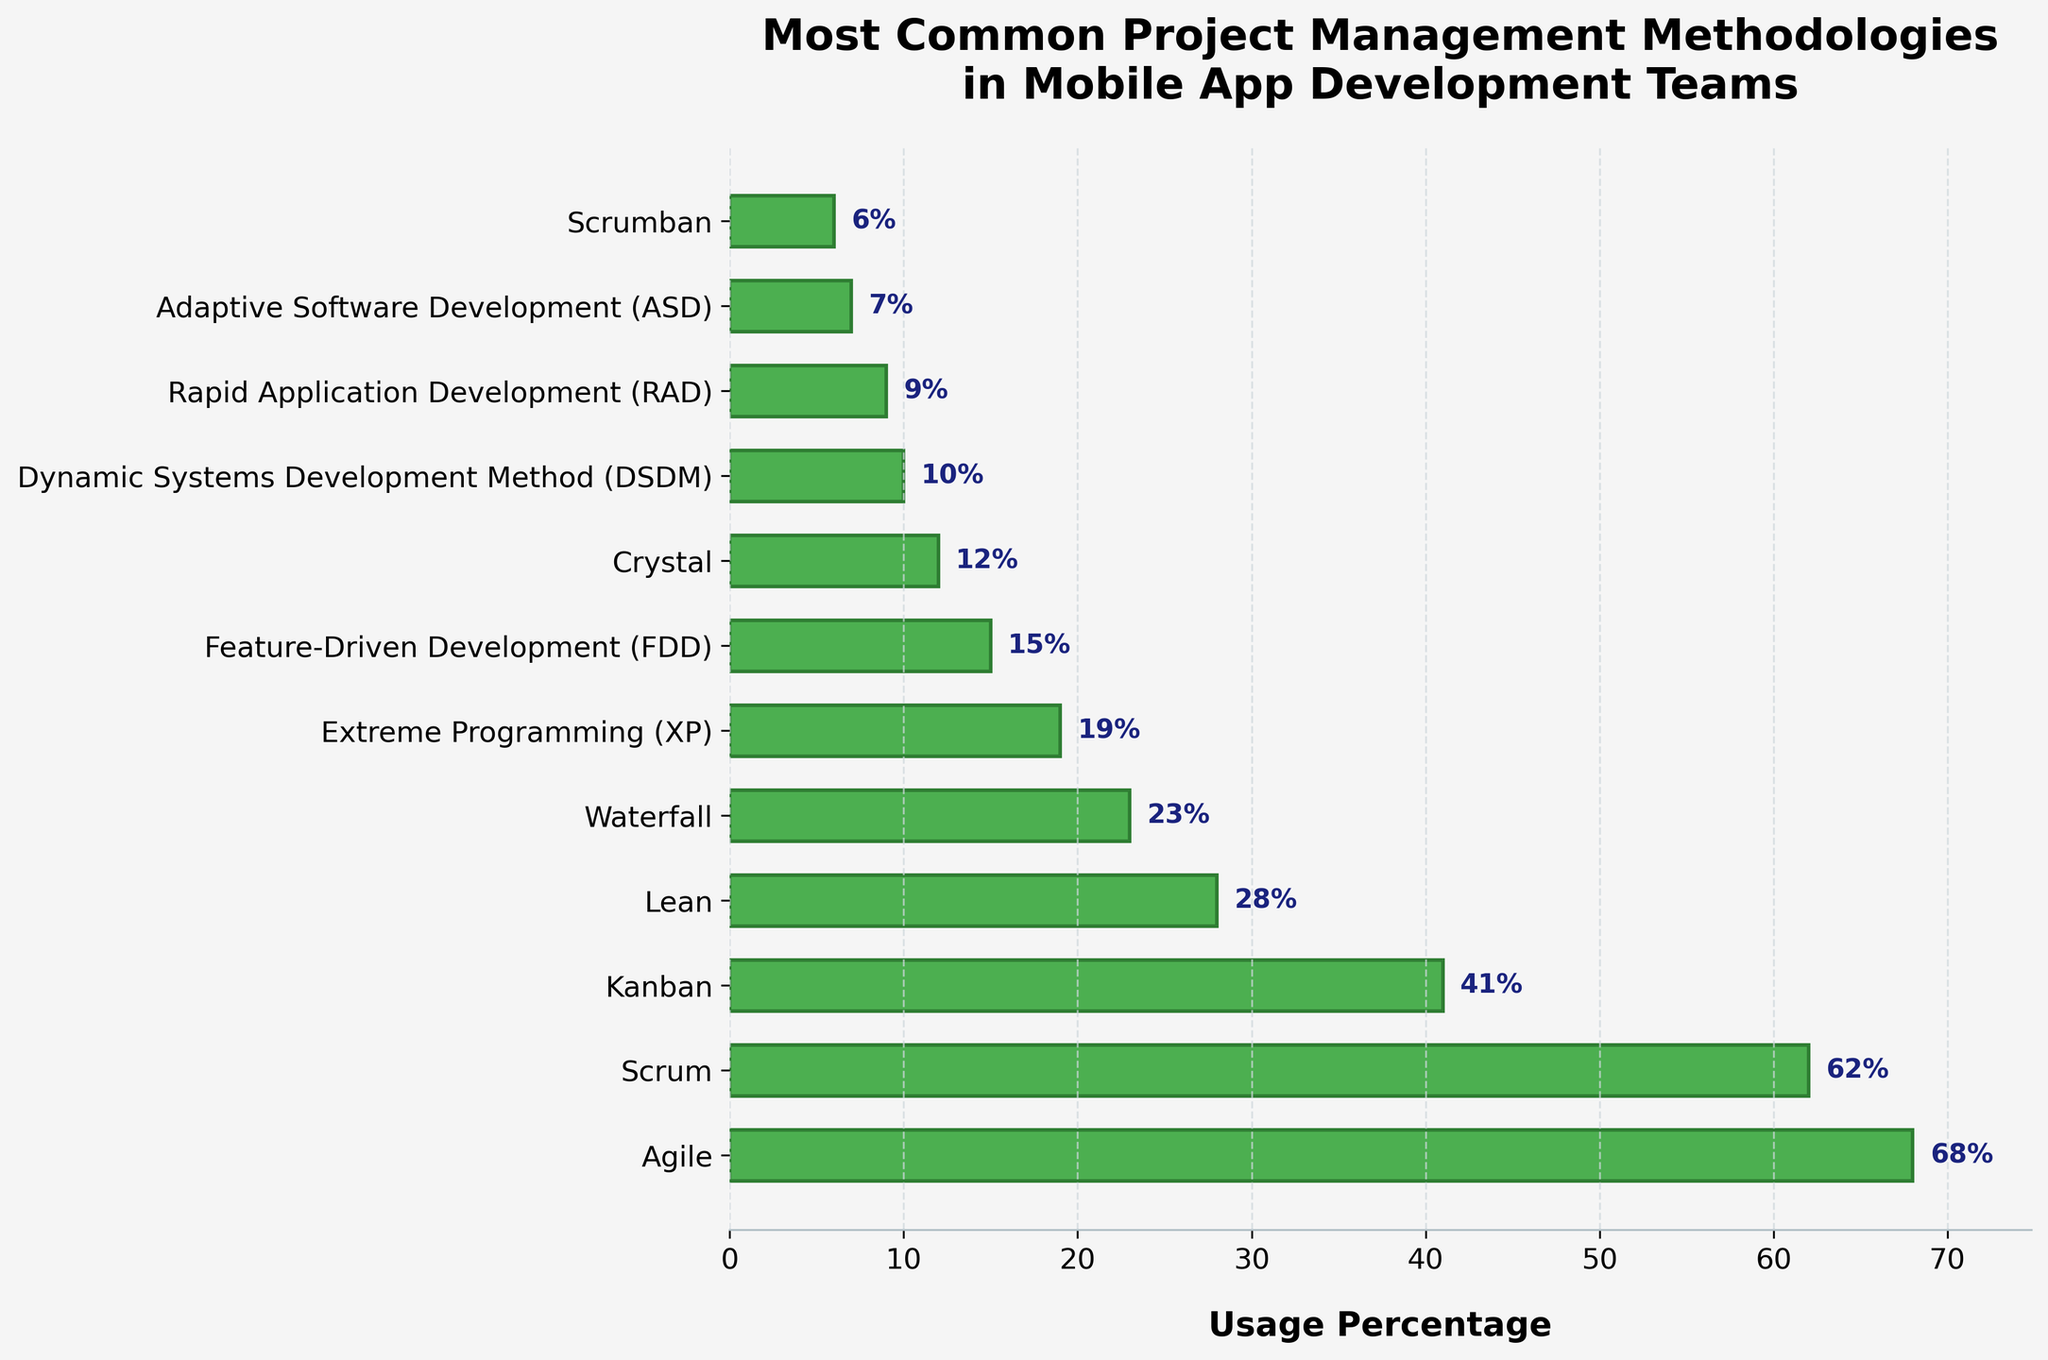What is the most commonly used project management methodology? The bar for Agile is the longest, indicating it has the highest usage percentage compared to the others.
Answer: Agile Which two methodologies are used by more than half of the mobile app development teams? The bars for Agile (68%) and Scrum (62%) exceed the 50% mark, indicating they are used by more than half of the teams.
Answer: Agile and Scrum What is the usage percentage of Kanban compared to Waterfall? The bar for Kanban is at 41% and the bar for Waterfall is at 23%. 41% - 23% shows Kanban is used 18 percentage points more.
Answer: 18 percentage points more Which methodology has the lowest usage percentage and what is it? The shortest bar on the chart represents Scrumban, which has the smallest value.
Answer: Scrumban (6%) How much more popular is Scrum compared to Extreme Programming (XP)? Scrum has a usage percentage of 62%, while Extreme Programming (XP) has 19%. 62% - 19% equals a 43 percentage points difference.
Answer: 43 percentage points more What is the total usage percentage for Lean and Adaptive Software Development (ASD)? Lean has 28% and Adaptive Software Development (ASD) has 7%. 28% + 7% equals 35%.
Answer: 35% Are there any methodologies with a usage percentage less than 10%? If so, which ones? DSDM (10%), RAD (9%), ASD (7%), and Scrumban (6%) have bars shorter than the 10% mark.
Answer: RAD, ASD, Scrumban Which methodology is used more: Crystal or Feature-Driven Development (FDD)? Crystal has 12% while Feature-Driven Development (FDD) has 15%. Therefore, FDD is used more.
Answer: Feature-Driven Development (FDD) Between Kanban and Lean, which has a higher usage percentage and by how much? Kanban has 41% and Lean has 28%. 41% - 28% equals a 13 percentage points difference.
Answer: Kanban by 13 percentage points How many methodologies have a usage percentage between 10% and 30%? According to the bars: Lean (28%), Waterfall (23%), Extreme Programming (XP) (19%), Feature-Driven Development (FDD) (15%), and Crystal (12%), they all lie between 10% and 30%.
Answer: 5 